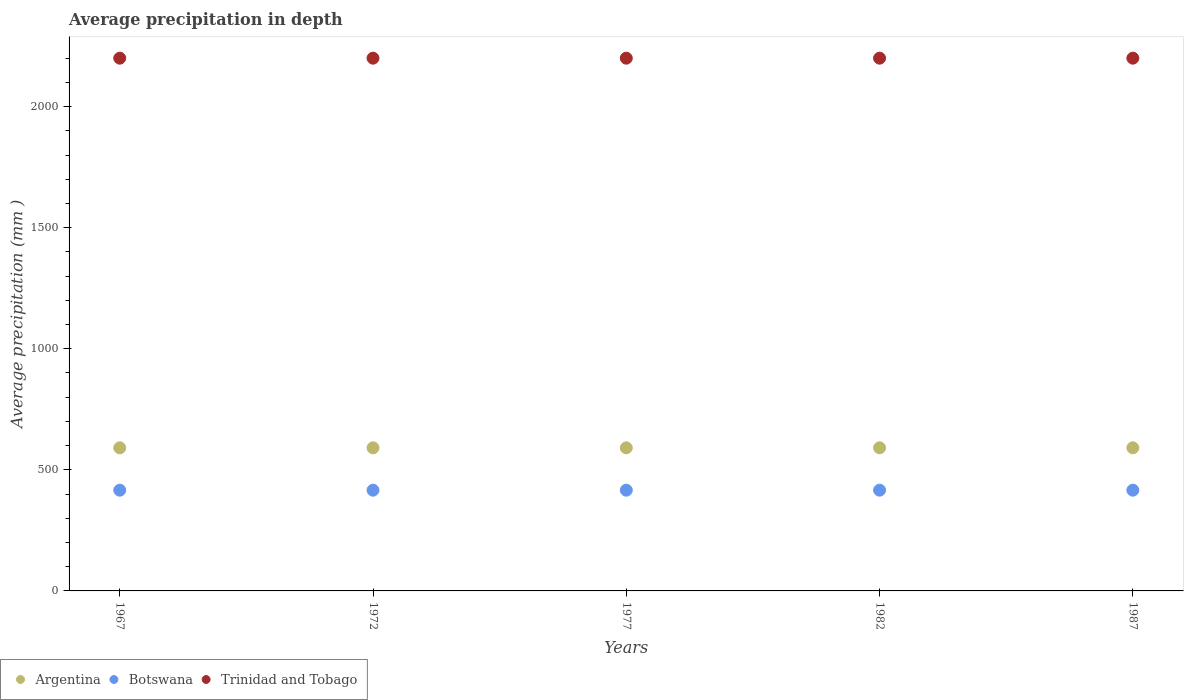How many different coloured dotlines are there?
Ensure brevity in your answer.  3. Is the number of dotlines equal to the number of legend labels?
Your answer should be very brief. Yes. What is the average precipitation in Botswana in 1972?
Offer a terse response. 416. Across all years, what is the maximum average precipitation in Trinidad and Tobago?
Keep it short and to the point. 2200. Across all years, what is the minimum average precipitation in Trinidad and Tobago?
Provide a succinct answer. 2200. In which year was the average precipitation in Trinidad and Tobago maximum?
Your answer should be very brief. 1967. In which year was the average precipitation in Botswana minimum?
Your answer should be compact. 1967. What is the total average precipitation in Trinidad and Tobago in the graph?
Provide a short and direct response. 1.10e+04. What is the difference between the average precipitation in Botswana in 1977 and that in 1987?
Ensure brevity in your answer.  0. What is the difference between the average precipitation in Argentina in 1967 and the average precipitation in Trinidad and Tobago in 1977?
Provide a short and direct response. -1609. What is the average average precipitation in Argentina per year?
Give a very brief answer. 591. In the year 1967, what is the difference between the average precipitation in Trinidad and Tobago and average precipitation in Botswana?
Your answer should be very brief. 1784. What is the ratio of the average precipitation in Botswana in 1967 to that in 1972?
Your answer should be compact. 1. Is the average precipitation in Argentina strictly greater than the average precipitation in Botswana over the years?
Provide a short and direct response. Yes. Is the average precipitation in Trinidad and Tobago strictly less than the average precipitation in Botswana over the years?
Provide a short and direct response. No. Are the values on the major ticks of Y-axis written in scientific E-notation?
Offer a very short reply. No. Does the graph contain any zero values?
Keep it short and to the point. No. How are the legend labels stacked?
Make the answer very short. Horizontal. What is the title of the graph?
Provide a succinct answer. Average precipitation in depth. What is the label or title of the X-axis?
Keep it short and to the point. Years. What is the label or title of the Y-axis?
Provide a succinct answer. Average precipitation (mm ). What is the Average precipitation (mm ) of Argentina in 1967?
Provide a short and direct response. 591. What is the Average precipitation (mm ) in Botswana in 1967?
Keep it short and to the point. 416. What is the Average precipitation (mm ) of Trinidad and Tobago in 1967?
Give a very brief answer. 2200. What is the Average precipitation (mm ) of Argentina in 1972?
Keep it short and to the point. 591. What is the Average precipitation (mm ) of Botswana in 1972?
Give a very brief answer. 416. What is the Average precipitation (mm ) in Trinidad and Tobago in 1972?
Keep it short and to the point. 2200. What is the Average precipitation (mm ) in Argentina in 1977?
Make the answer very short. 591. What is the Average precipitation (mm ) of Botswana in 1977?
Give a very brief answer. 416. What is the Average precipitation (mm ) in Trinidad and Tobago in 1977?
Your answer should be compact. 2200. What is the Average precipitation (mm ) in Argentina in 1982?
Your response must be concise. 591. What is the Average precipitation (mm ) of Botswana in 1982?
Your response must be concise. 416. What is the Average precipitation (mm ) of Trinidad and Tobago in 1982?
Make the answer very short. 2200. What is the Average precipitation (mm ) in Argentina in 1987?
Provide a short and direct response. 591. What is the Average precipitation (mm ) of Botswana in 1987?
Your answer should be compact. 416. What is the Average precipitation (mm ) in Trinidad and Tobago in 1987?
Provide a short and direct response. 2200. Across all years, what is the maximum Average precipitation (mm ) of Argentina?
Your answer should be very brief. 591. Across all years, what is the maximum Average precipitation (mm ) of Botswana?
Offer a very short reply. 416. Across all years, what is the maximum Average precipitation (mm ) of Trinidad and Tobago?
Give a very brief answer. 2200. Across all years, what is the minimum Average precipitation (mm ) in Argentina?
Give a very brief answer. 591. Across all years, what is the minimum Average precipitation (mm ) of Botswana?
Make the answer very short. 416. Across all years, what is the minimum Average precipitation (mm ) of Trinidad and Tobago?
Provide a succinct answer. 2200. What is the total Average precipitation (mm ) of Argentina in the graph?
Make the answer very short. 2955. What is the total Average precipitation (mm ) of Botswana in the graph?
Offer a very short reply. 2080. What is the total Average precipitation (mm ) of Trinidad and Tobago in the graph?
Give a very brief answer. 1.10e+04. What is the difference between the Average precipitation (mm ) in Argentina in 1967 and that in 1972?
Your answer should be very brief. 0. What is the difference between the Average precipitation (mm ) in Botswana in 1967 and that in 1977?
Provide a short and direct response. 0. What is the difference between the Average precipitation (mm ) in Trinidad and Tobago in 1967 and that in 1977?
Make the answer very short. 0. What is the difference between the Average precipitation (mm ) in Argentina in 1967 and that in 1982?
Make the answer very short. 0. What is the difference between the Average precipitation (mm ) of Botswana in 1967 and that in 1982?
Give a very brief answer. 0. What is the difference between the Average precipitation (mm ) in Argentina in 1967 and that in 1987?
Keep it short and to the point. 0. What is the difference between the Average precipitation (mm ) in Botswana in 1967 and that in 1987?
Ensure brevity in your answer.  0. What is the difference between the Average precipitation (mm ) in Argentina in 1972 and that in 1977?
Your answer should be compact. 0. What is the difference between the Average precipitation (mm ) of Trinidad and Tobago in 1972 and that in 1977?
Keep it short and to the point. 0. What is the difference between the Average precipitation (mm ) in Argentina in 1972 and that in 1987?
Give a very brief answer. 0. What is the difference between the Average precipitation (mm ) of Argentina in 1977 and that in 1982?
Your answer should be very brief. 0. What is the difference between the Average precipitation (mm ) in Trinidad and Tobago in 1977 and that in 1982?
Provide a succinct answer. 0. What is the difference between the Average precipitation (mm ) of Argentina in 1977 and that in 1987?
Make the answer very short. 0. What is the difference between the Average precipitation (mm ) of Botswana in 1977 and that in 1987?
Provide a short and direct response. 0. What is the difference between the Average precipitation (mm ) of Argentina in 1982 and that in 1987?
Give a very brief answer. 0. What is the difference between the Average precipitation (mm ) in Botswana in 1982 and that in 1987?
Ensure brevity in your answer.  0. What is the difference between the Average precipitation (mm ) of Argentina in 1967 and the Average precipitation (mm ) of Botswana in 1972?
Provide a short and direct response. 175. What is the difference between the Average precipitation (mm ) in Argentina in 1967 and the Average precipitation (mm ) in Trinidad and Tobago in 1972?
Give a very brief answer. -1609. What is the difference between the Average precipitation (mm ) of Botswana in 1967 and the Average precipitation (mm ) of Trinidad and Tobago in 1972?
Your response must be concise. -1784. What is the difference between the Average precipitation (mm ) of Argentina in 1967 and the Average precipitation (mm ) of Botswana in 1977?
Your answer should be compact. 175. What is the difference between the Average precipitation (mm ) of Argentina in 1967 and the Average precipitation (mm ) of Trinidad and Tobago in 1977?
Your answer should be very brief. -1609. What is the difference between the Average precipitation (mm ) in Botswana in 1967 and the Average precipitation (mm ) in Trinidad and Tobago in 1977?
Make the answer very short. -1784. What is the difference between the Average precipitation (mm ) in Argentina in 1967 and the Average precipitation (mm ) in Botswana in 1982?
Offer a very short reply. 175. What is the difference between the Average precipitation (mm ) in Argentina in 1967 and the Average precipitation (mm ) in Trinidad and Tobago in 1982?
Offer a terse response. -1609. What is the difference between the Average precipitation (mm ) in Botswana in 1967 and the Average precipitation (mm ) in Trinidad and Tobago in 1982?
Give a very brief answer. -1784. What is the difference between the Average precipitation (mm ) in Argentina in 1967 and the Average precipitation (mm ) in Botswana in 1987?
Offer a terse response. 175. What is the difference between the Average precipitation (mm ) of Argentina in 1967 and the Average precipitation (mm ) of Trinidad and Tobago in 1987?
Provide a short and direct response. -1609. What is the difference between the Average precipitation (mm ) in Botswana in 1967 and the Average precipitation (mm ) in Trinidad and Tobago in 1987?
Your answer should be compact. -1784. What is the difference between the Average precipitation (mm ) of Argentina in 1972 and the Average precipitation (mm ) of Botswana in 1977?
Offer a very short reply. 175. What is the difference between the Average precipitation (mm ) of Argentina in 1972 and the Average precipitation (mm ) of Trinidad and Tobago in 1977?
Provide a short and direct response. -1609. What is the difference between the Average precipitation (mm ) in Botswana in 1972 and the Average precipitation (mm ) in Trinidad and Tobago in 1977?
Keep it short and to the point. -1784. What is the difference between the Average precipitation (mm ) of Argentina in 1972 and the Average precipitation (mm ) of Botswana in 1982?
Provide a short and direct response. 175. What is the difference between the Average precipitation (mm ) of Argentina in 1972 and the Average precipitation (mm ) of Trinidad and Tobago in 1982?
Offer a very short reply. -1609. What is the difference between the Average precipitation (mm ) in Botswana in 1972 and the Average precipitation (mm ) in Trinidad and Tobago in 1982?
Ensure brevity in your answer.  -1784. What is the difference between the Average precipitation (mm ) of Argentina in 1972 and the Average precipitation (mm ) of Botswana in 1987?
Keep it short and to the point. 175. What is the difference between the Average precipitation (mm ) in Argentina in 1972 and the Average precipitation (mm ) in Trinidad and Tobago in 1987?
Offer a terse response. -1609. What is the difference between the Average precipitation (mm ) of Botswana in 1972 and the Average precipitation (mm ) of Trinidad and Tobago in 1987?
Offer a very short reply. -1784. What is the difference between the Average precipitation (mm ) in Argentina in 1977 and the Average precipitation (mm ) in Botswana in 1982?
Keep it short and to the point. 175. What is the difference between the Average precipitation (mm ) in Argentina in 1977 and the Average precipitation (mm ) in Trinidad and Tobago in 1982?
Your answer should be very brief. -1609. What is the difference between the Average precipitation (mm ) in Botswana in 1977 and the Average precipitation (mm ) in Trinidad and Tobago in 1982?
Offer a terse response. -1784. What is the difference between the Average precipitation (mm ) of Argentina in 1977 and the Average precipitation (mm ) of Botswana in 1987?
Keep it short and to the point. 175. What is the difference between the Average precipitation (mm ) in Argentina in 1977 and the Average precipitation (mm ) in Trinidad and Tobago in 1987?
Your answer should be very brief. -1609. What is the difference between the Average precipitation (mm ) in Botswana in 1977 and the Average precipitation (mm ) in Trinidad and Tobago in 1987?
Offer a very short reply. -1784. What is the difference between the Average precipitation (mm ) in Argentina in 1982 and the Average precipitation (mm ) in Botswana in 1987?
Your response must be concise. 175. What is the difference between the Average precipitation (mm ) of Argentina in 1982 and the Average precipitation (mm ) of Trinidad and Tobago in 1987?
Your answer should be very brief. -1609. What is the difference between the Average precipitation (mm ) of Botswana in 1982 and the Average precipitation (mm ) of Trinidad and Tobago in 1987?
Offer a terse response. -1784. What is the average Average precipitation (mm ) in Argentina per year?
Provide a succinct answer. 591. What is the average Average precipitation (mm ) of Botswana per year?
Provide a short and direct response. 416. What is the average Average precipitation (mm ) of Trinidad and Tobago per year?
Offer a very short reply. 2200. In the year 1967, what is the difference between the Average precipitation (mm ) of Argentina and Average precipitation (mm ) of Botswana?
Offer a very short reply. 175. In the year 1967, what is the difference between the Average precipitation (mm ) in Argentina and Average precipitation (mm ) in Trinidad and Tobago?
Your answer should be compact. -1609. In the year 1967, what is the difference between the Average precipitation (mm ) in Botswana and Average precipitation (mm ) in Trinidad and Tobago?
Make the answer very short. -1784. In the year 1972, what is the difference between the Average precipitation (mm ) in Argentina and Average precipitation (mm ) in Botswana?
Your response must be concise. 175. In the year 1972, what is the difference between the Average precipitation (mm ) in Argentina and Average precipitation (mm ) in Trinidad and Tobago?
Provide a short and direct response. -1609. In the year 1972, what is the difference between the Average precipitation (mm ) of Botswana and Average precipitation (mm ) of Trinidad and Tobago?
Give a very brief answer. -1784. In the year 1977, what is the difference between the Average precipitation (mm ) in Argentina and Average precipitation (mm ) in Botswana?
Provide a succinct answer. 175. In the year 1977, what is the difference between the Average precipitation (mm ) in Argentina and Average precipitation (mm ) in Trinidad and Tobago?
Your response must be concise. -1609. In the year 1977, what is the difference between the Average precipitation (mm ) of Botswana and Average precipitation (mm ) of Trinidad and Tobago?
Give a very brief answer. -1784. In the year 1982, what is the difference between the Average precipitation (mm ) in Argentina and Average precipitation (mm ) in Botswana?
Ensure brevity in your answer.  175. In the year 1982, what is the difference between the Average precipitation (mm ) in Argentina and Average precipitation (mm ) in Trinidad and Tobago?
Your response must be concise. -1609. In the year 1982, what is the difference between the Average precipitation (mm ) in Botswana and Average precipitation (mm ) in Trinidad and Tobago?
Give a very brief answer. -1784. In the year 1987, what is the difference between the Average precipitation (mm ) of Argentina and Average precipitation (mm ) of Botswana?
Make the answer very short. 175. In the year 1987, what is the difference between the Average precipitation (mm ) in Argentina and Average precipitation (mm ) in Trinidad and Tobago?
Your answer should be compact. -1609. In the year 1987, what is the difference between the Average precipitation (mm ) in Botswana and Average precipitation (mm ) in Trinidad and Tobago?
Offer a very short reply. -1784. What is the ratio of the Average precipitation (mm ) in Botswana in 1967 to that in 1972?
Make the answer very short. 1. What is the ratio of the Average precipitation (mm ) of Trinidad and Tobago in 1967 to that in 1972?
Keep it short and to the point. 1. What is the ratio of the Average precipitation (mm ) of Botswana in 1967 to that in 1977?
Provide a succinct answer. 1. What is the ratio of the Average precipitation (mm ) of Argentina in 1967 to that in 1982?
Provide a succinct answer. 1. What is the ratio of the Average precipitation (mm ) in Argentina in 1972 to that in 1977?
Your answer should be compact. 1. What is the ratio of the Average precipitation (mm ) in Trinidad and Tobago in 1972 to that in 1977?
Keep it short and to the point. 1. What is the ratio of the Average precipitation (mm ) of Botswana in 1972 to that in 1982?
Ensure brevity in your answer.  1. What is the ratio of the Average precipitation (mm ) in Trinidad and Tobago in 1972 to that in 1982?
Your answer should be compact. 1. What is the ratio of the Average precipitation (mm ) in Argentina in 1972 to that in 1987?
Make the answer very short. 1. What is the ratio of the Average precipitation (mm ) in Trinidad and Tobago in 1972 to that in 1987?
Offer a terse response. 1. What is the ratio of the Average precipitation (mm ) in Botswana in 1977 to that in 1982?
Provide a succinct answer. 1. What is the ratio of the Average precipitation (mm ) of Trinidad and Tobago in 1977 to that in 1987?
Ensure brevity in your answer.  1. What is the ratio of the Average precipitation (mm ) in Argentina in 1982 to that in 1987?
Offer a very short reply. 1. What is the ratio of the Average precipitation (mm ) in Trinidad and Tobago in 1982 to that in 1987?
Provide a succinct answer. 1. What is the difference between the highest and the second highest Average precipitation (mm ) in Argentina?
Give a very brief answer. 0. What is the difference between the highest and the second highest Average precipitation (mm ) in Botswana?
Offer a very short reply. 0. What is the difference between the highest and the lowest Average precipitation (mm ) of Argentina?
Your answer should be compact. 0. What is the difference between the highest and the lowest Average precipitation (mm ) in Botswana?
Ensure brevity in your answer.  0. 